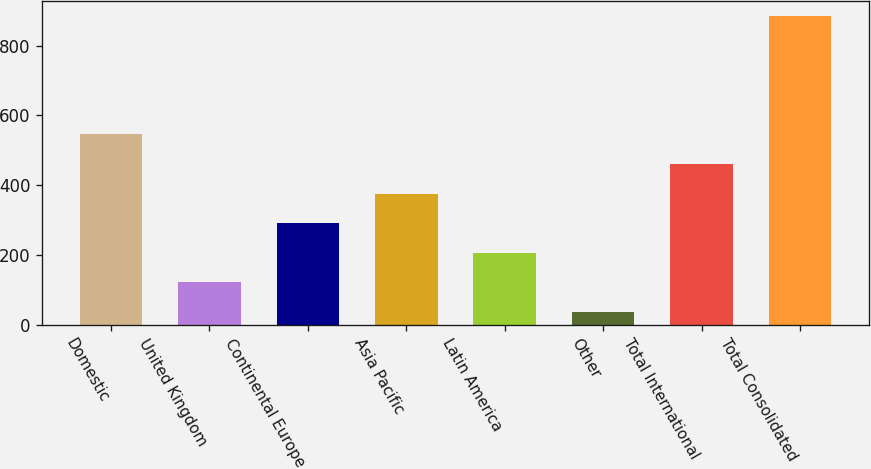Convert chart to OTSL. <chart><loc_0><loc_0><loc_500><loc_500><bar_chart><fcel>Domestic<fcel>United Kingdom<fcel>Continental Europe<fcel>Asia Pacific<fcel>Latin America<fcel>Other<fcel>Total International<fcel>Total Consolidated<nl><fcel>545.7<fcel>121.82<fcel>291.26<fcel>375.98<fcel>206.54<fcel>37.1<fcel>460.7<fcel>884.3<nl></chart> 